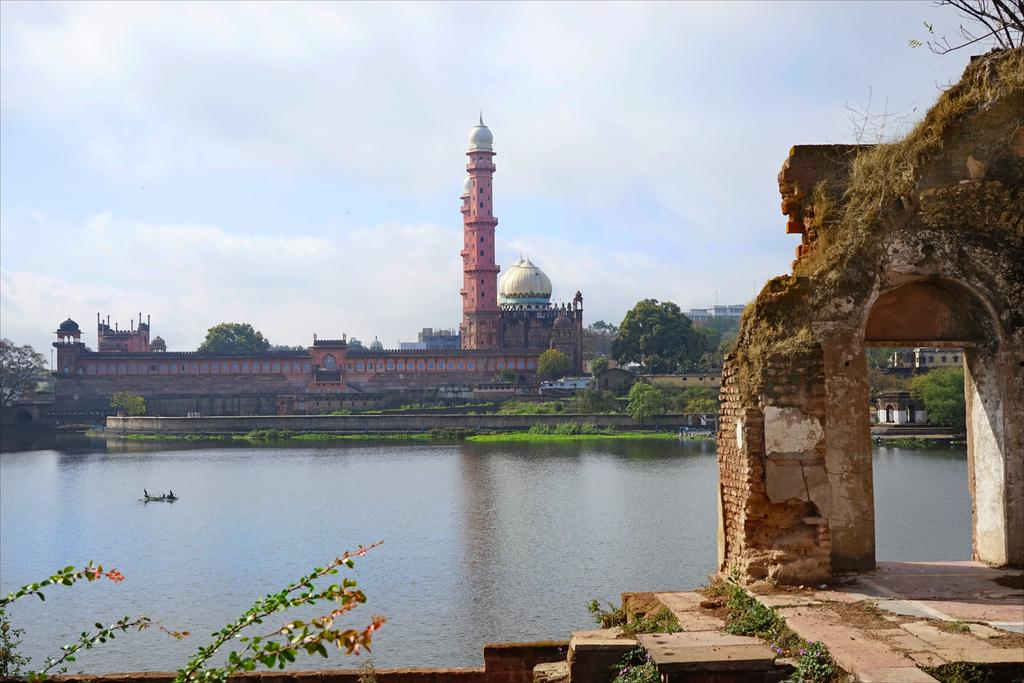What is the weather like in the image? The sky is cloudy in the image. What type of structures can be seen in the image? There are buildings in the image. What type of vegetation is present in the image? There are trees in the image. What natural element is visible in the image? There is water visible in the image. Where is the girl sitting on the train in the image? There is no girl or train present in the image. What type of place is depicted in the image? The image does not depict a specific place; it shows a combination of natural and man-made elements. 